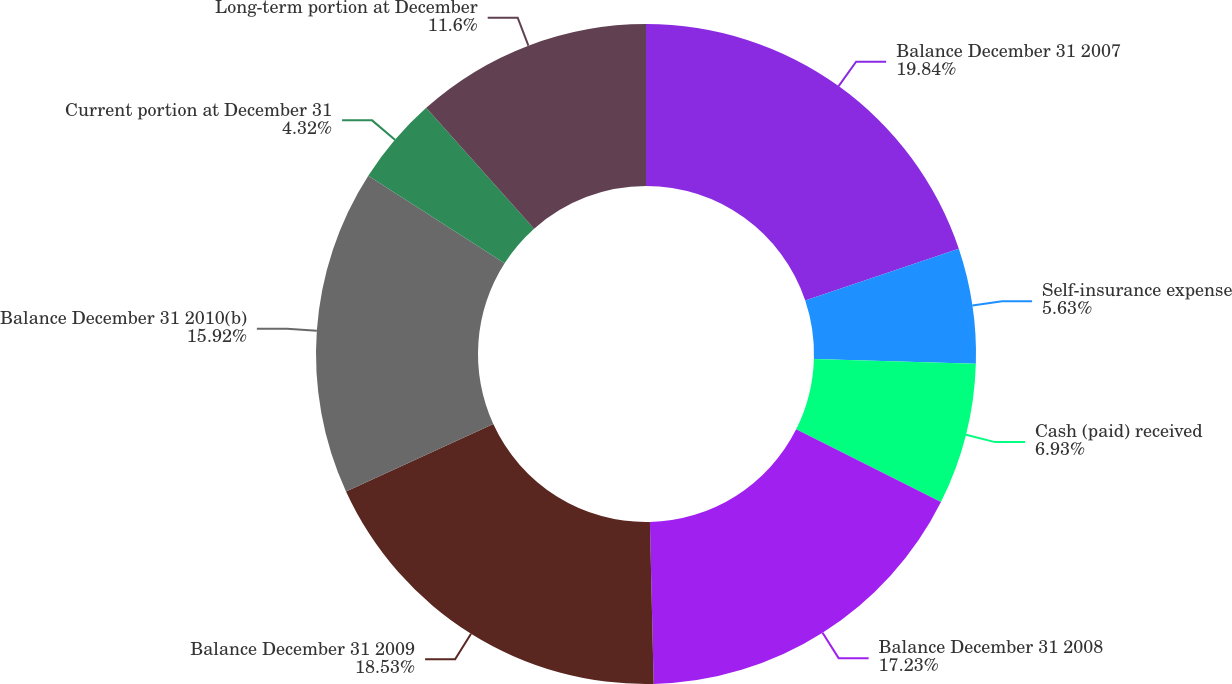<chart> <loc_0><loc_0><loc_500><loc_500><pie_chart><fcel>Balance December 31 2007<fcel>Self-insurance expense<fcel>Cash (paid) received<fcel>Balance December 31 2008<fcel>Balance December 31 2009<fcel>Balance December 31 2010(b)<fcel>Current portion at December 31<fcel>Long-term portion at December<nl><fcel>19.84%<fcel>5.63%<fcel>6.93%<fcel>17.23%<fcel>18.53%<fcel>15.92%<fcel>4.32%<fcel>11.6%<nl></chart> 